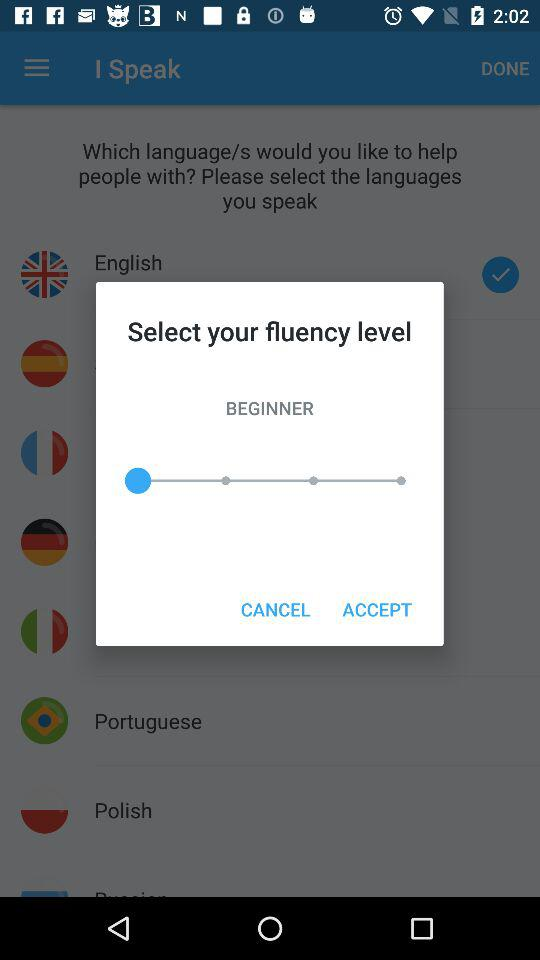What is the selected fluency level? The selected fluency level is "BEGINNER". 